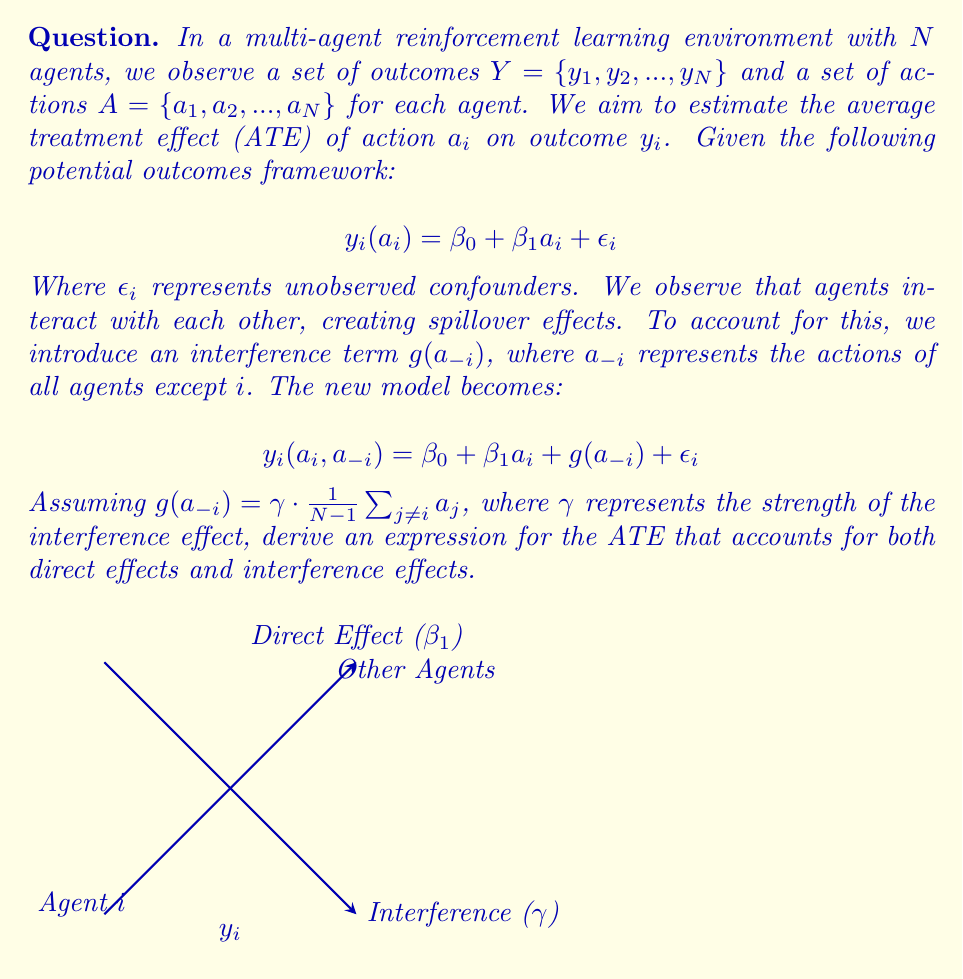Show me your answer to this math problem. Let's approach this step-by-step:

1) The Average Treatment Effect (ATE) is defined as the difference in expected outcomes between treated and untreated units:

   $$ATE = E[y_i(1, a_{-i})] - E[y_i(0, a_{-i})]$$

2) Using our model, we can expand this:

   $$ATE = E[\beta_0 + \beta_1 \cdot 1 + g(a_{-i}) + \epsilon_i] - E[\beta_0 + \beta_1 \cdot 0 + g(a_{-i}) + \epsilon_i]$$

3) The $\beta_0$, $g(a_{-i})$, and $\epsilon_i$ terms cancel out:

   $$ATE = E[\beta_1]$$

4) However, this only accounts for the direct effect. We need to consider the interference effect as well. When agent $i$ changes its action, it affects the outcomes of other agents, which in turn affects agent $i$ through the interference term.

5) The total effect includes both the direct effect and the feedback from the interference:

   $$Total Effect = Direct Effect + Interference Effect$$

6) The interference effect on agent $i$ when it changes its action is:

   $$Interference Effect = \gamma \cdot \frac{1}{N-1} \cdot (N-1) \cdot \frac{1}{N} = \frac{\gamma}{N}$$

   This is because changing $a_i$ from 0 to 1 increases the average action of other agents by $\frac{1}{N}$.

7) Therefore, the total ATE is:

   $$ATE = \beta_1 + \frac{\gamma}{N}$$

This expression accounts for both the direct effect ($\beta_1$) and the interference effect ($\frac{\gamma}{N}$) in estimating the average treatment effect in this multi-agent reinforcement learning environment.
Answer: $$ATE = \beta_1 + \frac{\gamma}{N}$$ 